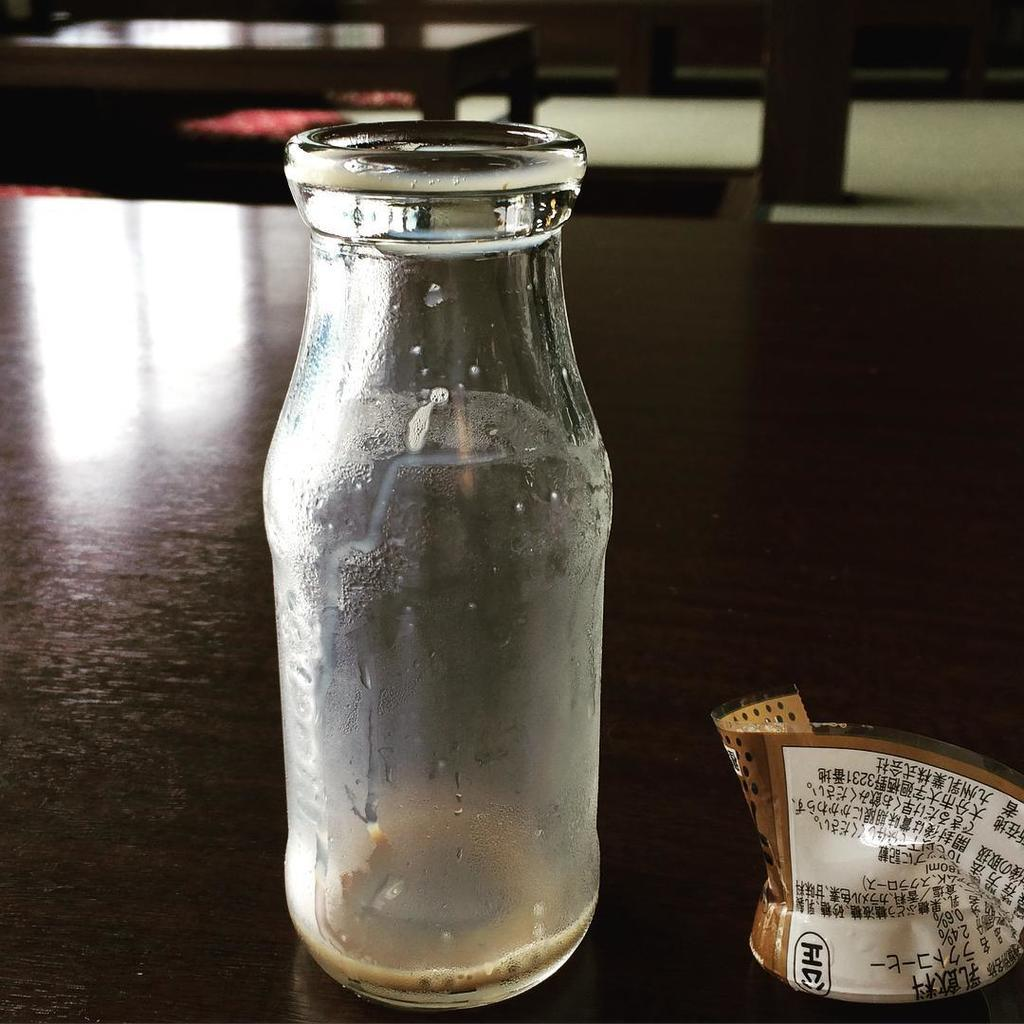What is the main object in the image? There is an empty bottle in the image. What is the condition of the bottle's label? The label of the bottle is torn. Where is the torn label placed in relation to the bottle? The torn label is kept beside the bottle. On what surface are the bottle and label placed? Both the bottle and the label are on a table. What type of horn is placed on the table next to the bottle? There is no horn present in the image; it only features an empty bottle and a torn label. 